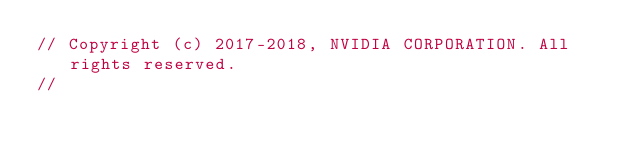Convert code to text. <code><loc_0><loc_0><loc_500><loc_500><_Cuda_>// Copyright (c) 2017-2018, NVIDIA CORPORATION. All rights reserved.
//</code> 